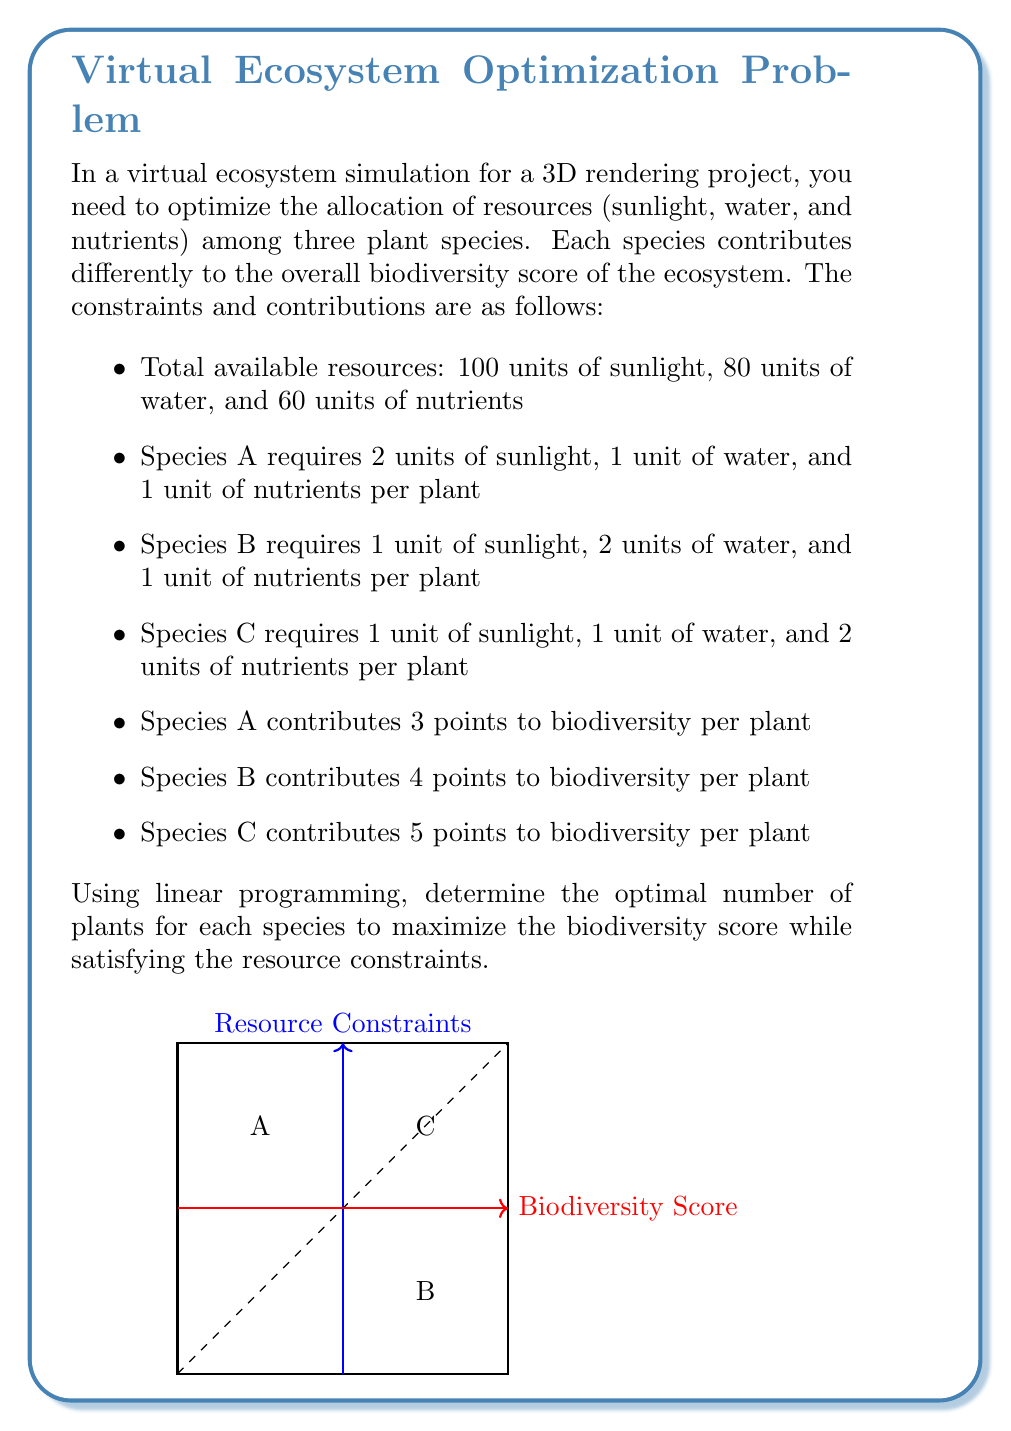Could you help me with this problem? To solve this linear programming problem, we'll follow these steps:

1) Define variables:
   Let $x$, $y$, and $z$ be the number of plants for Species A, B, and C respectively.

2) Set up the objective function to maximize biodiversity:
   Maximize $f(x,y,z) = 3x + 4y + 5z$

3) Define the constraints:
   Sunlight: $2x + y + z \leq 100$
   Water: $x + 2y + z \leq 80$
   Nutrients: $x + y + 2z \leq 60$
   Non-negativity: $x, y, z \geq 0$

4) Solve using the simplex method or a linear programming solver. For this explanation, we'll use the graphical method as we have only three variables.

5) The feasible region is the intersection of all constraints. The optimal solution will be at one of the corner points of this region.

6) Evaluate the objective function at each corner point:
   (0, 0, 0): $f(0,0,0) = 0$
   (50, 0, 0): $f(50,0,0) = 150$
   (0, 40, 0): $f(0,40,0) = 160$
   (0, 0, 30): $f(0,0,30) = 150$
   (20, 30, 0): $f(20,30,0) = 180$
   (40, 0, 10): $f(40,0,10) = 170$
   (0, 20, 20): $f(0,20,20) = 180$

7) The maximum biodiversity score is achieved at two points: (20, 30, 0) and (0, 20, 20), both giving a score of 180.

8) For 3D rendering purposes, we might prefer a mix of all three species. We can choose a point slightly inside the feasible region, such as (18, 28, 2), which gives a biodiversity score of 178 while including all species.
Answer: Optimal solution: 18 plants of Species A, 28 plants of Species B, and 2 plants of Species C. 